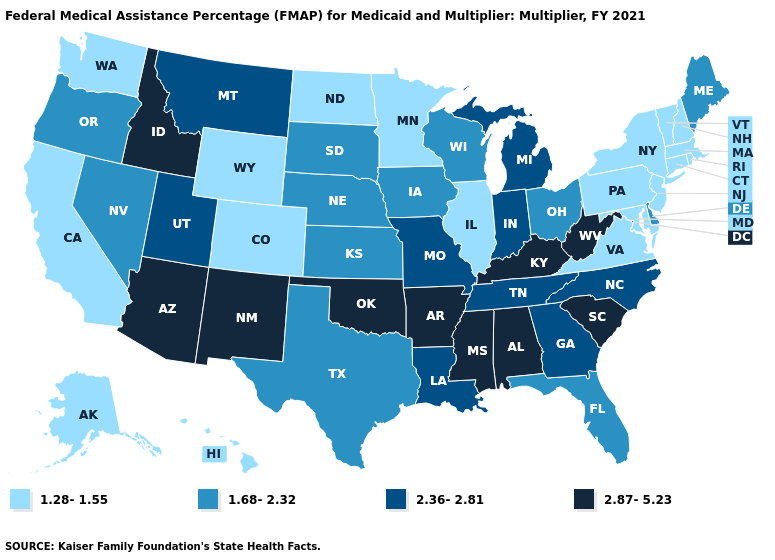How many symbols are there in the legend?
Give a very brief answer. 4. What is the value of Connecticut?
Keep it brief. 1.28-1.55. Name the states that have a value in the range 1.28-1.55?
Answer briefly. Alaska, California, Colorado, Connecticut, Hawaii, Illinois, Maryland, Massachusetts, Minnesota, New Hampshire, New Jersey, New York, North Dakota, Pennsylvania, Rhode Island, Vermont, Virginia, Washington, Wyoming. Which states hav the highest value in the West?
Write a very short answer. Arizona, Idaho, New Mexico. Among the states that border South Dakota , which have the lowest value?
Short answer required. Minnesota, North Dakota, Wyoming. Does the map have missing data?
Write a very short answer. No. What is the value of New Mexico?
Be succinct. 2.87-5.23. Which states have the lowest value in the USA?
Answer briefly. Alaska, California, Colorado, Connecticut, Hawaii, Illinois, Maryland, Massachusetts, Minnesota, New Hampshire, New Jersey, New York, North Dakota, Pennsylvania, Rhode Island, Vermont, Virginia, Washington, Wyoming. What is the value of Connecticut?
Answer briefly. 1.28-1.55. How many symbols are there in the legend?
Concise answer only. 4. What is the lowest value in the USA?
Give a very brief answer. 1.28-1.55. What is the lowest value in the USA?
Give a very brief answer. 1.28-1.55. Does Alabama have the highest value in the South?
Give a very brief answer. Yes. What is the value of Maryland?
Answer briefly. 1.28-1.55. What is the value of Kentucky?
Answer briefly. 2.87-5.23. 